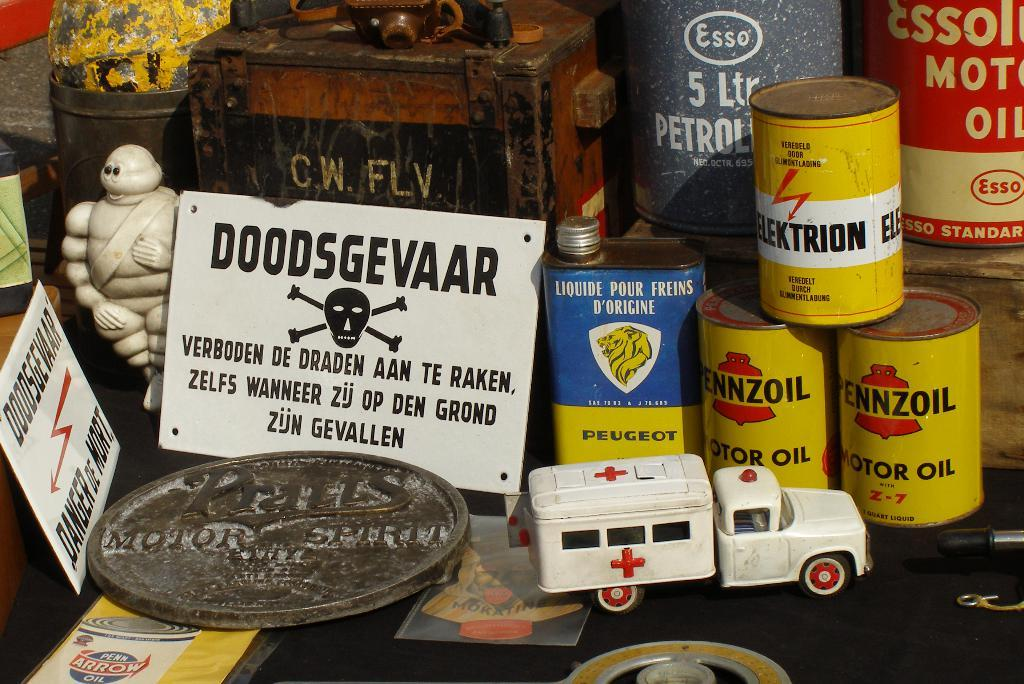<image>
Present a compact description of the photo's key features. A display of car products including Pennzoil Motor Oil. 